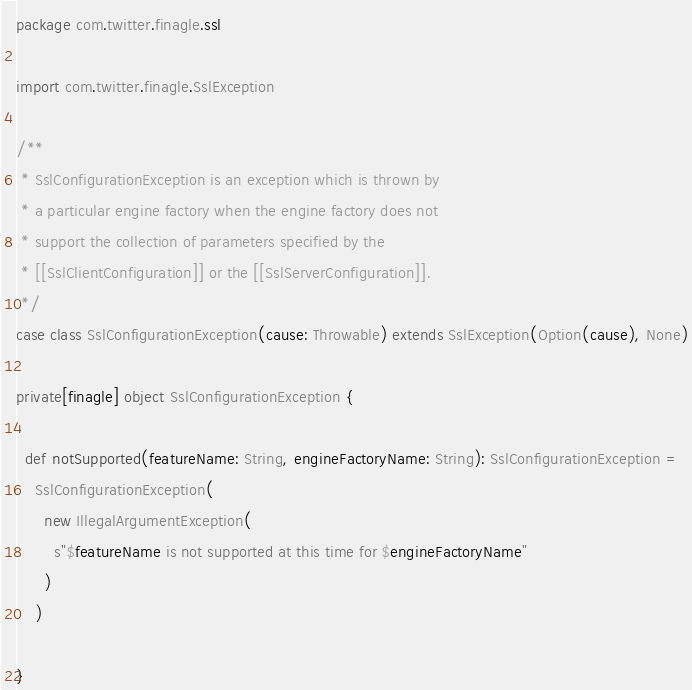<code> <loc_0><loc_0><loc_500><loc_500><_Scala_>package com.twitter.finagle.ssl

import com.twitter.finagle.SslException

/**
 * SslConfigurationException is an exception which is thrown by
 * a particular engine factory when the engine factory does not
 * support the collection of parameters specified by the
 * [[SslClientConfiguration]] or the [[SslServerConfiguration]].
 */
case class SslConfigurationException(cause: Throwable) extends SslException(Option(cause), None)

private[finagle] object SslConfigurationException {

  def notSupported(featureName: String, engineFactoryName: String): SslConfigurationException =
    SslConfigurationException(
      new IllegalArgumentException(
        s"$featureName is not supported at this time for $engineFactoryName"
      )
    )

}
</code> 